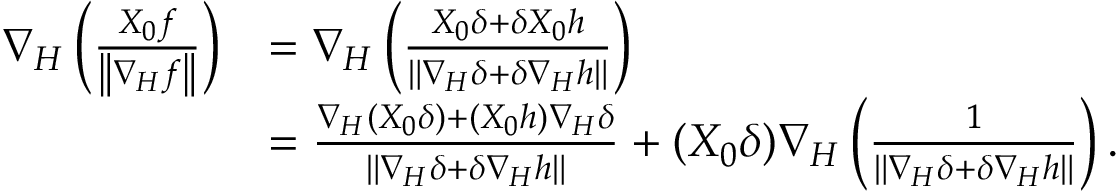<formula> <loc_0><loc_0><loc_500><loc_500>\begin{array} { r l } { \nabla _ { H } \left ( \frac { X _ { 0 } f } { \left \| \nabla _ { H } f \right \| } \right ) } & { = \nabla _ { H } \left ( \frac { X _ { 0 } \delta + \delta X _ { 0 } h } { \left \| \nabla _ { H } \delta + \delta \nabla _ { H } h \right \| } \right ) } \\ & { = \frac { \nabla _ { H } ( X _ { 0 } \delta ) + ( X _ { 0 } h ) \nabla _ { H } \delta } { \left \| \nabla _ { H } \delta + \delta \nabla _ { H } h \right \| } + ( X _ { 0 } \delta ) \nabla _ { H } \left ( \frac { 1 } { \left \| \nabla _ { H } \delta + \delta \nabla _ { H } h \right \| } \right ) . } \end{array}</formula> 